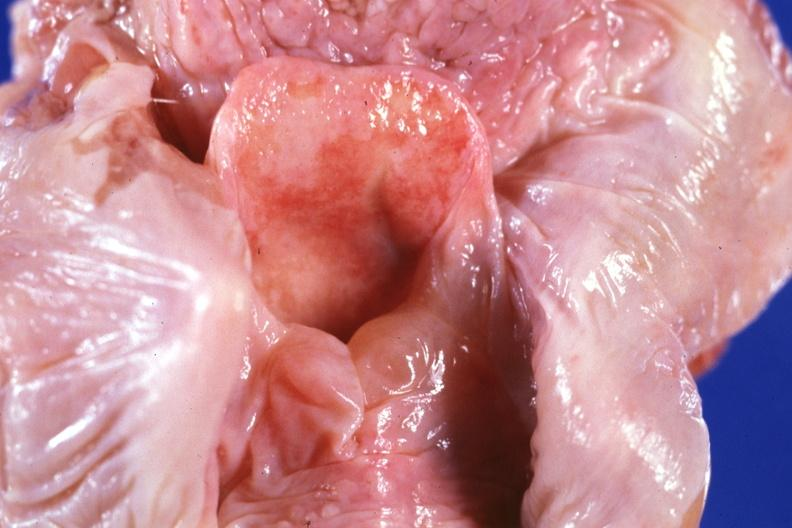what does this image show?
Answer the question using a single word or phrase. Unopened larynx seen from above edema really is in hypopharynx 